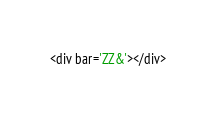Convert code to text. <code><loc_0><loc_0><loc_500><loc_500><_HTML_><div bar='ZZ&'></div>
</code> 